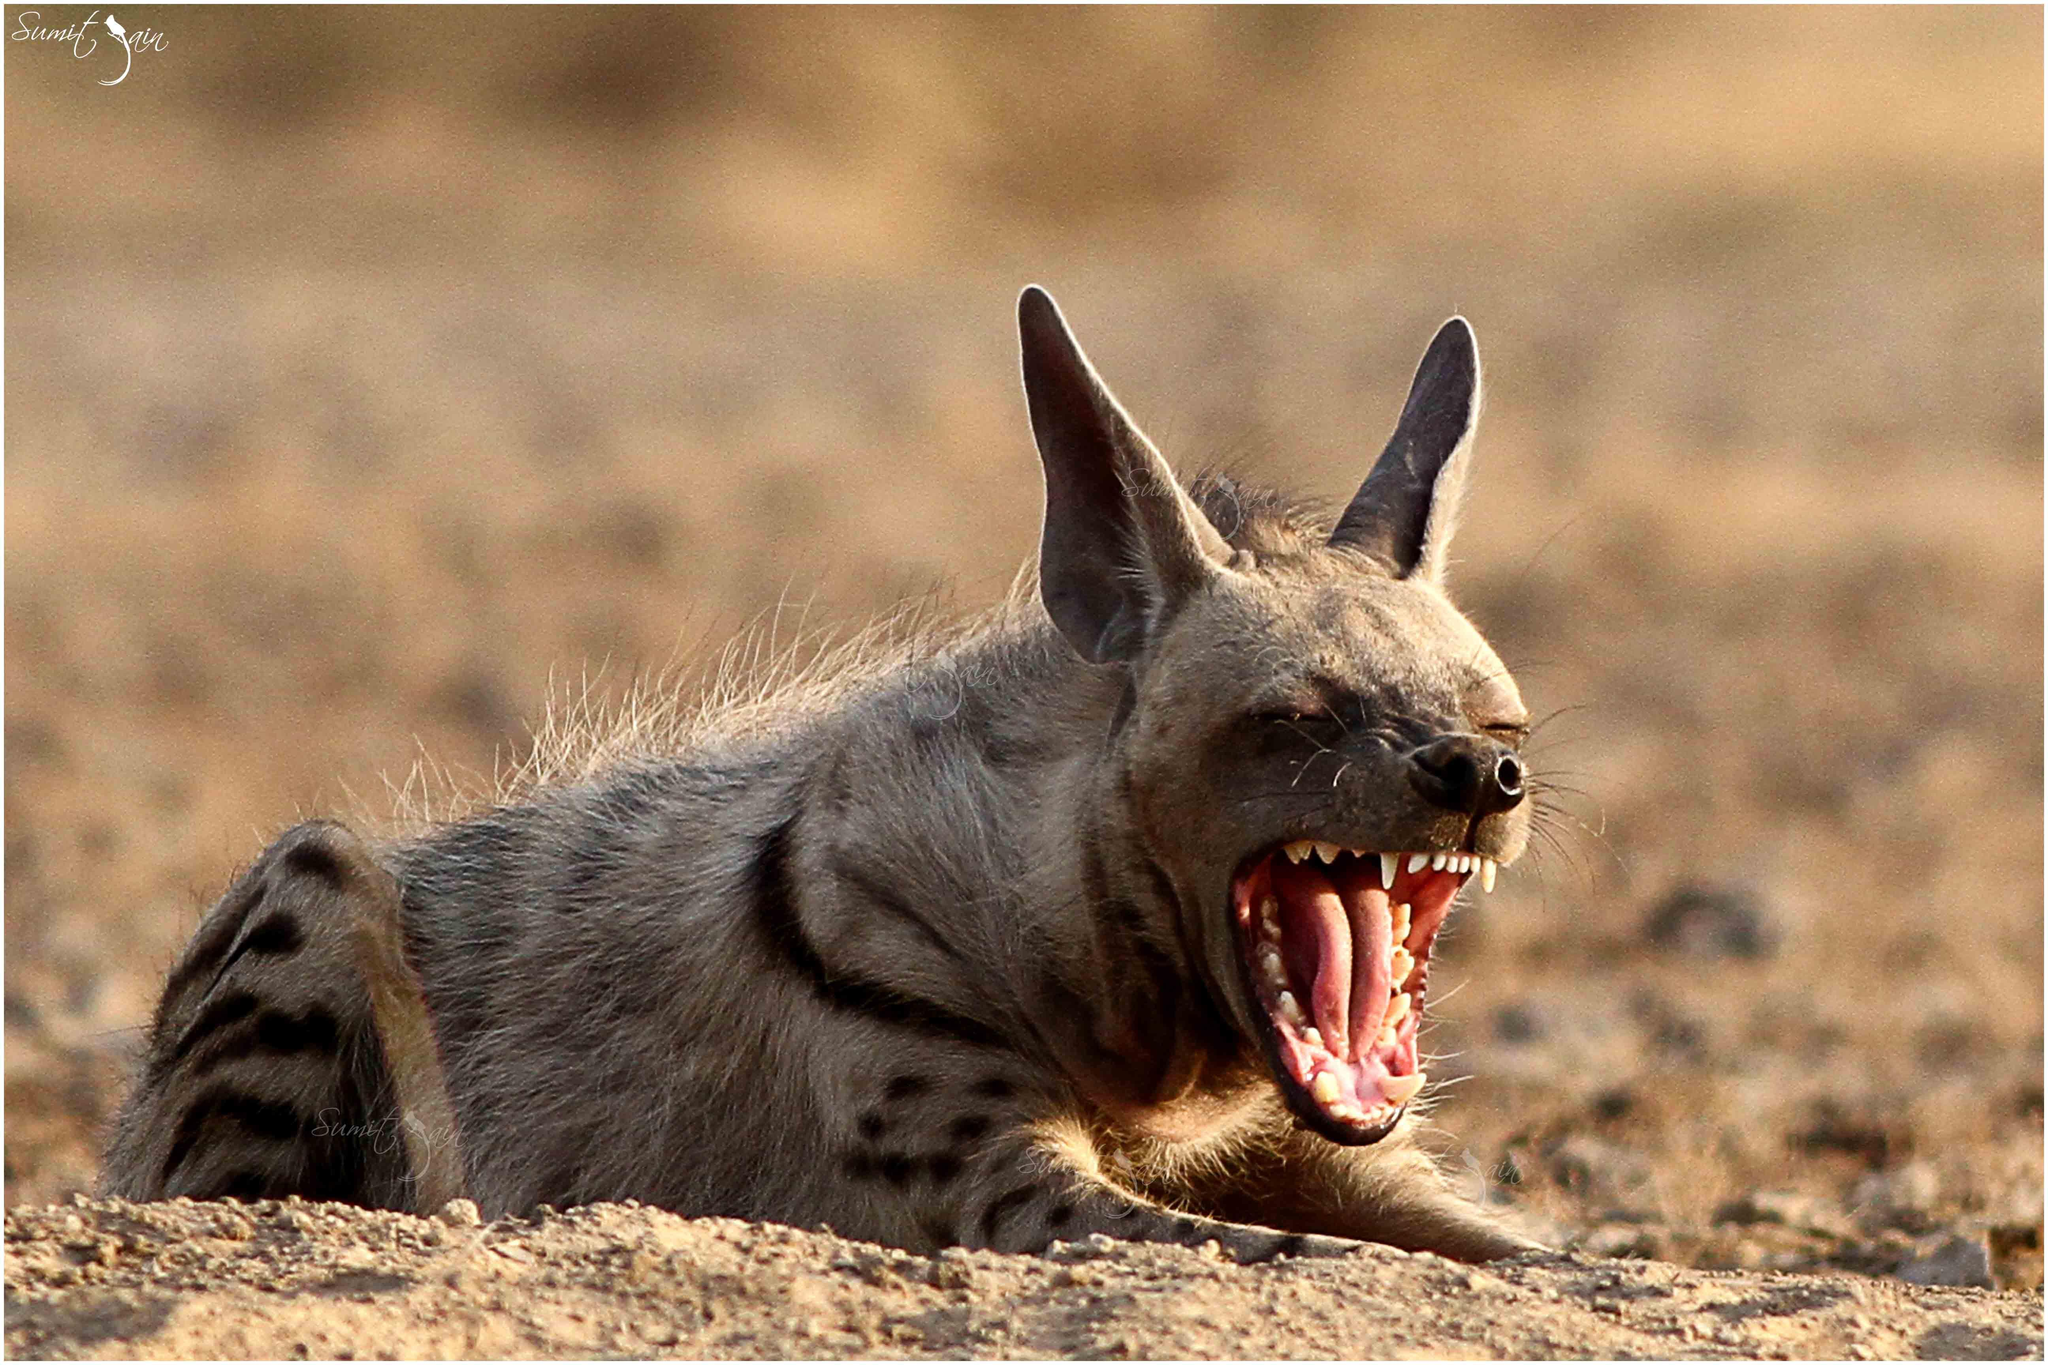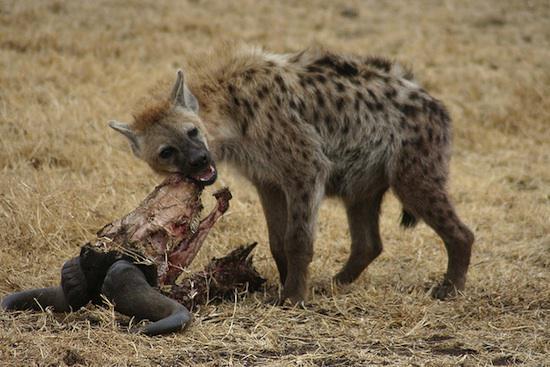The first image is the image on the left, the second image is the image on the right. Considering the images on both sides, is "The left and right image contains the same number of hyenas." valid? Answer yes or no. Yes. The first image is the image on the left, the second image is the image on the right. Assess this claim about the two images: "Neither image in the pair shows a hyena with it's mouth opened and teeth exposed.". Correct or not? Answer yes or no. No. 